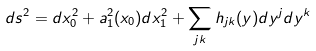<formula> <loc_0><loc_0><loc_500><loc_500>d s ^ { 2 } = d x _ { 0 } ^ { 2 } + a _ { 1 } ^ { 2 } ( x _ { 0 } ) d x _ { 1 } ^ { 2 } + \sum _ { j k } h _ { j k } ( y ) d y ^ { j } d y ^ { k }</formula> 